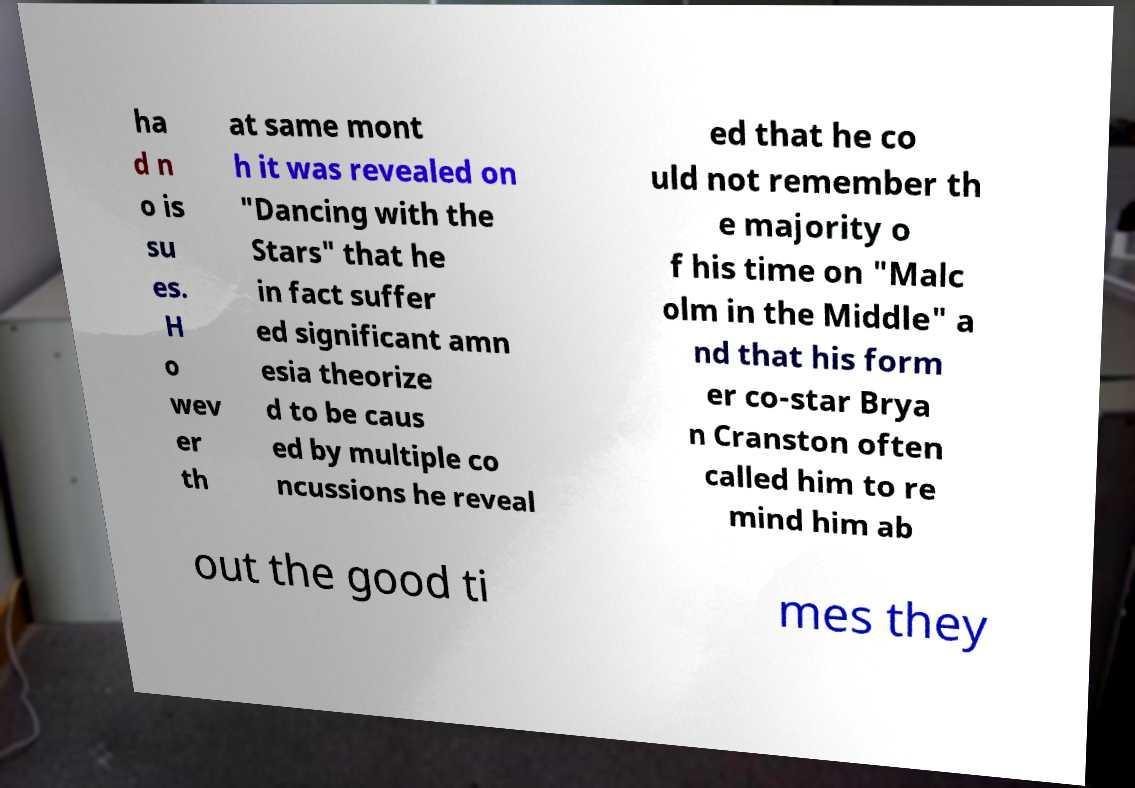Could you extract and type out the text from this image? ha d n o is su es. H o wev er th at same mont h it was revealed on "Dancing with the Stars" that he in fact suffer ed significant amn esia theorize d to be caus ed by multiple co ncussions he reveal ed that he co uld not remember th e majority o f his time on "Malc olm in the Middle" a nd that his form er co-star Brya n Cranston often called him to re mind him ab out the good ti mes they 